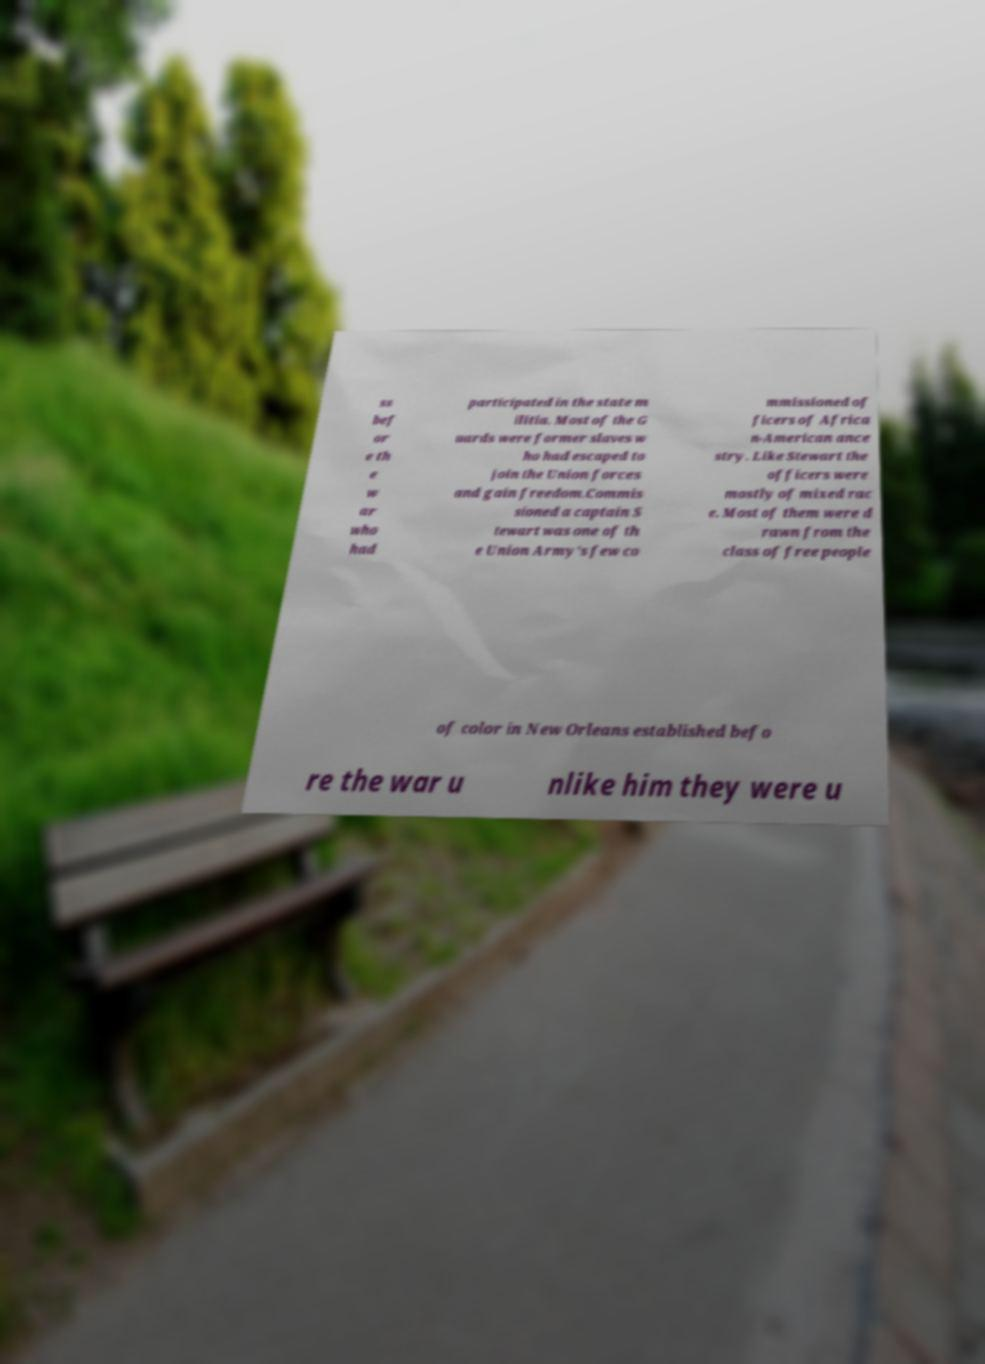Please identify and transcribe the text found in this image. ss bef or e th e w ar who had participated in the state m ilitia. Most of the G uards were former slaves w ho had escaped to join the Union forces and gain freedom.Commis sioned a captain S tewart was one of th e Union Army's few co mmissioned of ficers of Africa n-American ance stry. Like Stewart the officers were mostly of mixed rac e. Most of them were d rawn from the class of free people of color in New Orleans established befo re the war u nlike him they were u 